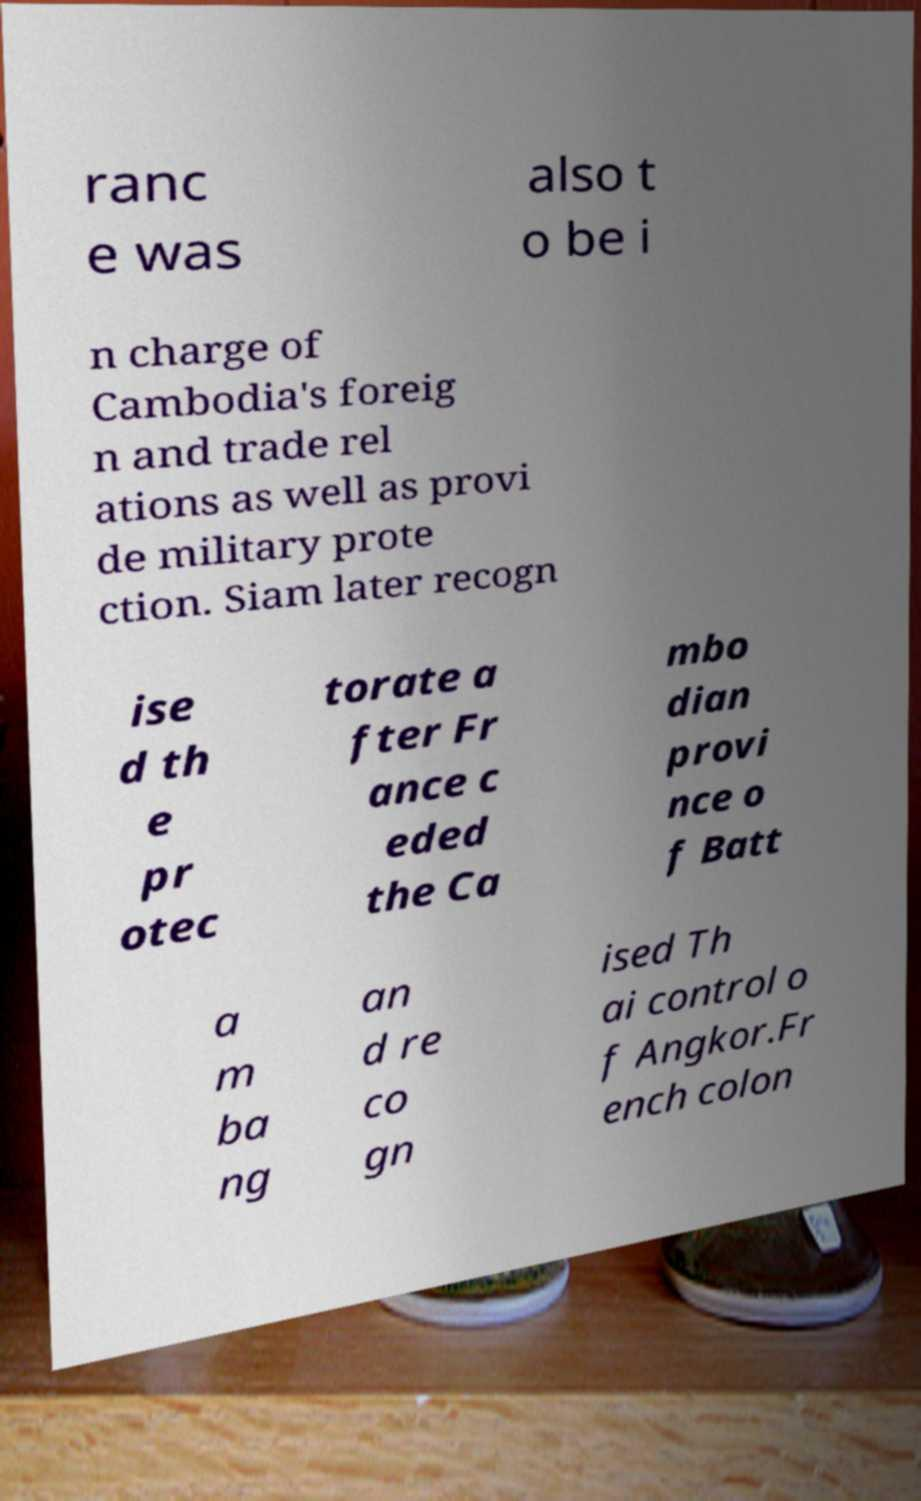Please identify and transcribe the text found in this image. ranc e was also t o be i n charge of Cambodia's foreig n and trade rel ations as well as provi de military prote ction. Siam later recogn ise d th e pr otec torate a fter Fr ance c eded the Ca mbo dian provi nce o f Batt a m ba ng an d re co gn ised Th ai control o f Angkor.Fr ench colon 